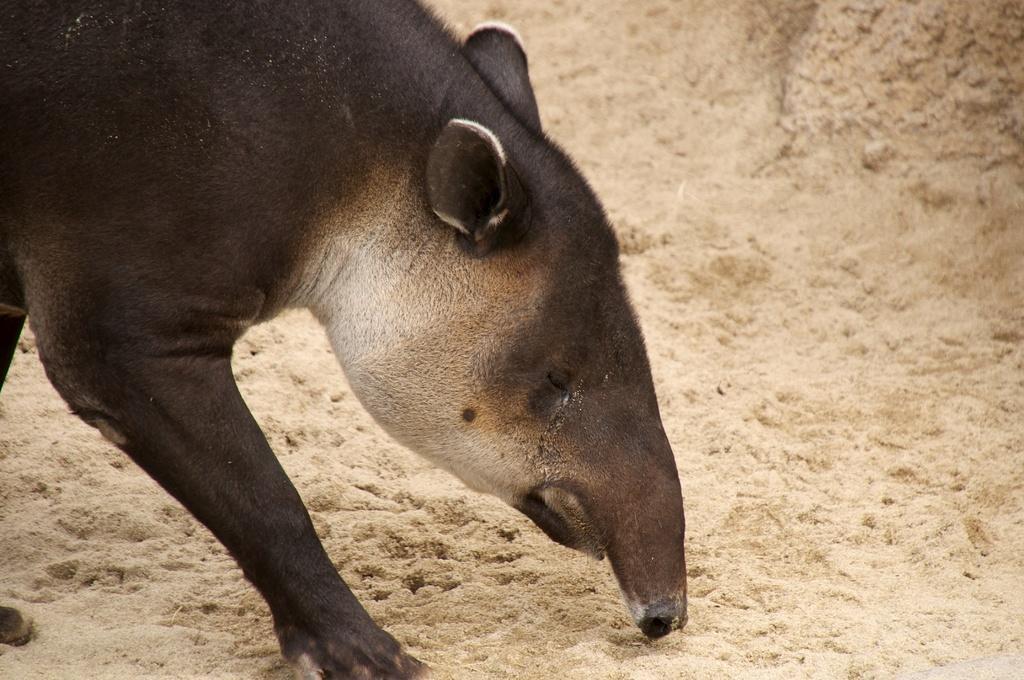How would you summarize this image in a sentence or two? In this image we can see an animal. In the background there is sand. 